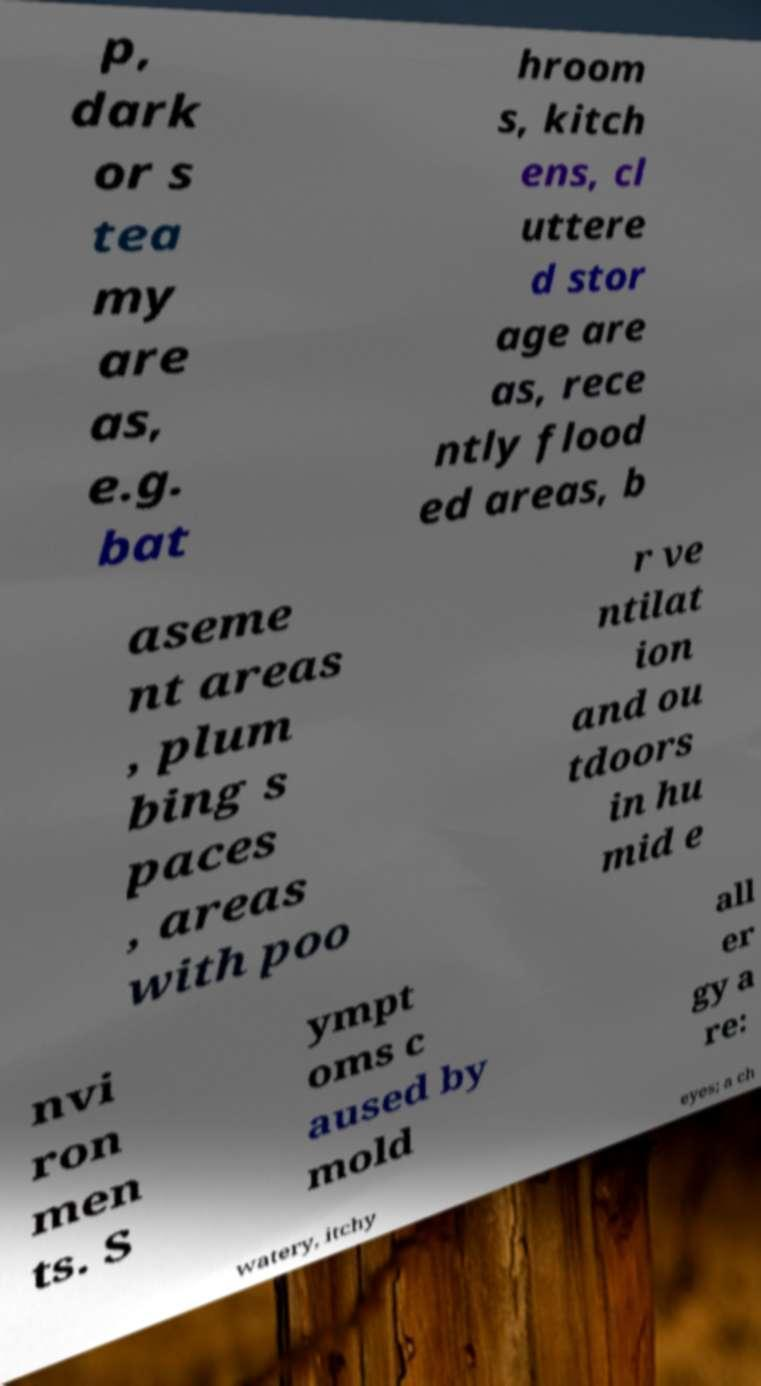Please identify and transcribe the text found in this image. p, dark or s tea my are as, e.g. bat hroom s, kitch ens, cl uttere d stor age are as, rece ntly flood ed areas, b aseme nt areas , plum bing s paces , areas with poo r ve ntilat ion and ou tdoors in hu mid e nvi ron men ts. S ympt oms c aused by mold all er gy a re: watery, itchy eyes; a ch 